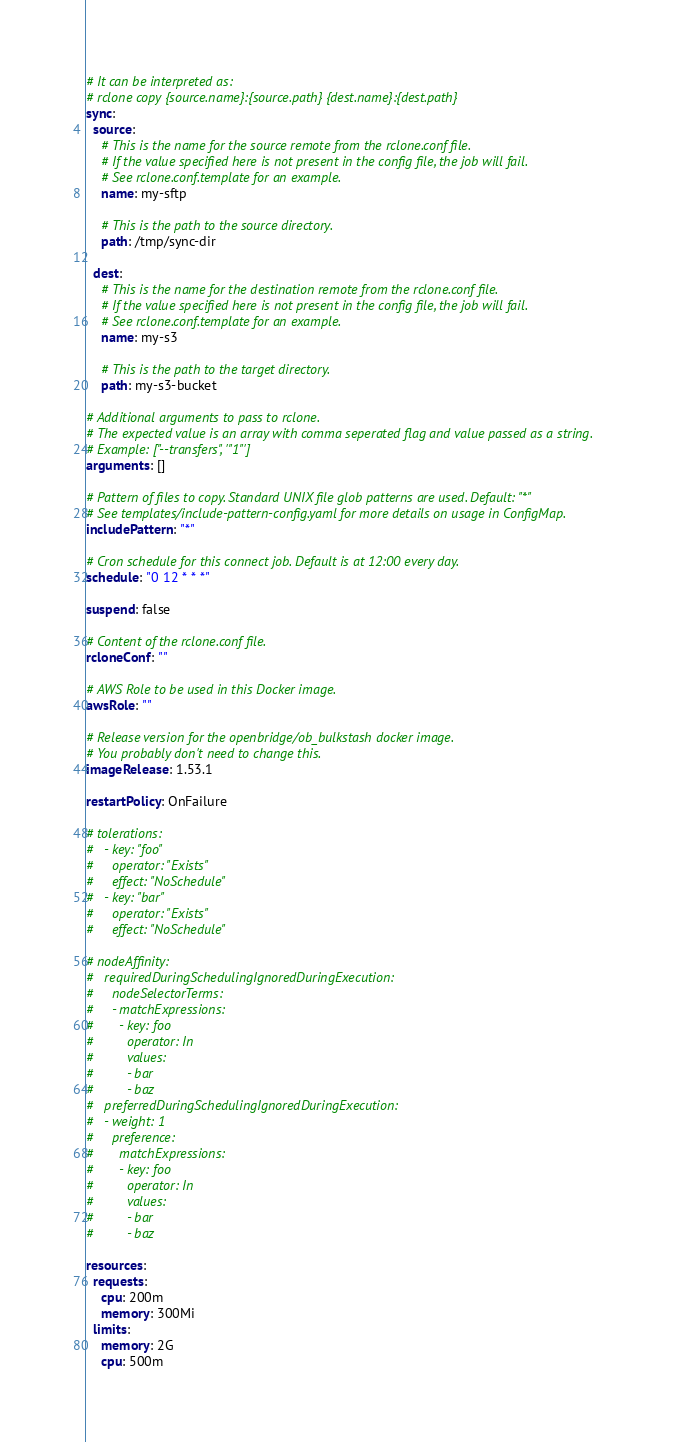<code> <loc_0><loc_0><loc_500><loc_500><_YAML_># It can be interpreted as:
# rclone copy {source.name}:{source.path} {dest.name}:{dest.path}
sync:
  source:
    # This is the name for the source remote from the rclone.conf file.
    # If the value specified here is not present in the config file, the job will fail.
    # See rclone.conf.template for an example.
    name: my-sftp

    # This is the path to the source directory.
    path: /tmp/sync-dir

  dest:
    # This is the name for the destination remote from the rclone.conf file.
    # If the value specified here is not present in the config file, the job will fail.
    # See rclone.conf.template for an example.
    name: my-s3

    # This is the path to the target directory.
    path: my-s3-bucket

# Additional arguments to pass to rclone. 
# The expected value is an array with comma seperated flag and value passed as a string. 
# Example: ["--transfers", '"1"']
arguments: []

# Pattern of files to copy. Standard UNIX file glob patterns are used. Default: "*"
# See templates/include-pattern-config.yaml for more details on usage in ConfigMap.
includePattern: "*"

# Cron schedule for this connect job. Default is at 12:00 every day.
schedule: "0 12 * * *"

suspend: false

# Content of the rclone.conf file.
rcloneConf: ""

# AWS Role to be used in this Docker image.
awsRole: ""

# Release version for the openbridge/ob_bulkstash docker image.
# You probably don't need to change this.
imageRelease: 1.53.1

restartPolicy: OnFailure

# tolerations:
#   - key: "foo"
#     operator: "Exists"
#     effect: "NoSchedule"
#   - key: "bar"
#     operator: "Exists"
#     effect: "NoSchedule"

# nodeAffinity:
#   requiredDuringSchedulingIgnoredDuringExecution:
#     nodeSelectorTerms:
#     - matchExpressions:
#       - key: foo
#         operator: In
#         values:
#         - bar
#         - baz
#   preferredDuringSchedulingIgnoredDuringExecution:
#   - weight: 1
#     preference:
#       matchExpressions:
#       - key: foo
#         operator: In
#         values:
#         - bar
#         - baz

resources:
  requests:
    cpu: 200m
    memory: 300Mi
  limits:
    memory: 2G
    cpu: 500m
</code> 